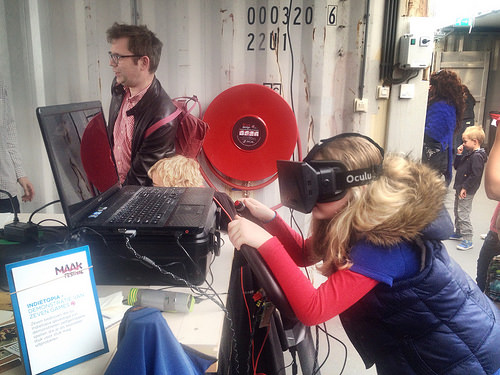<image>
Is there a man next to the table? Yes. The man is positioned adjacent to the table, located nearby in the same general area. 